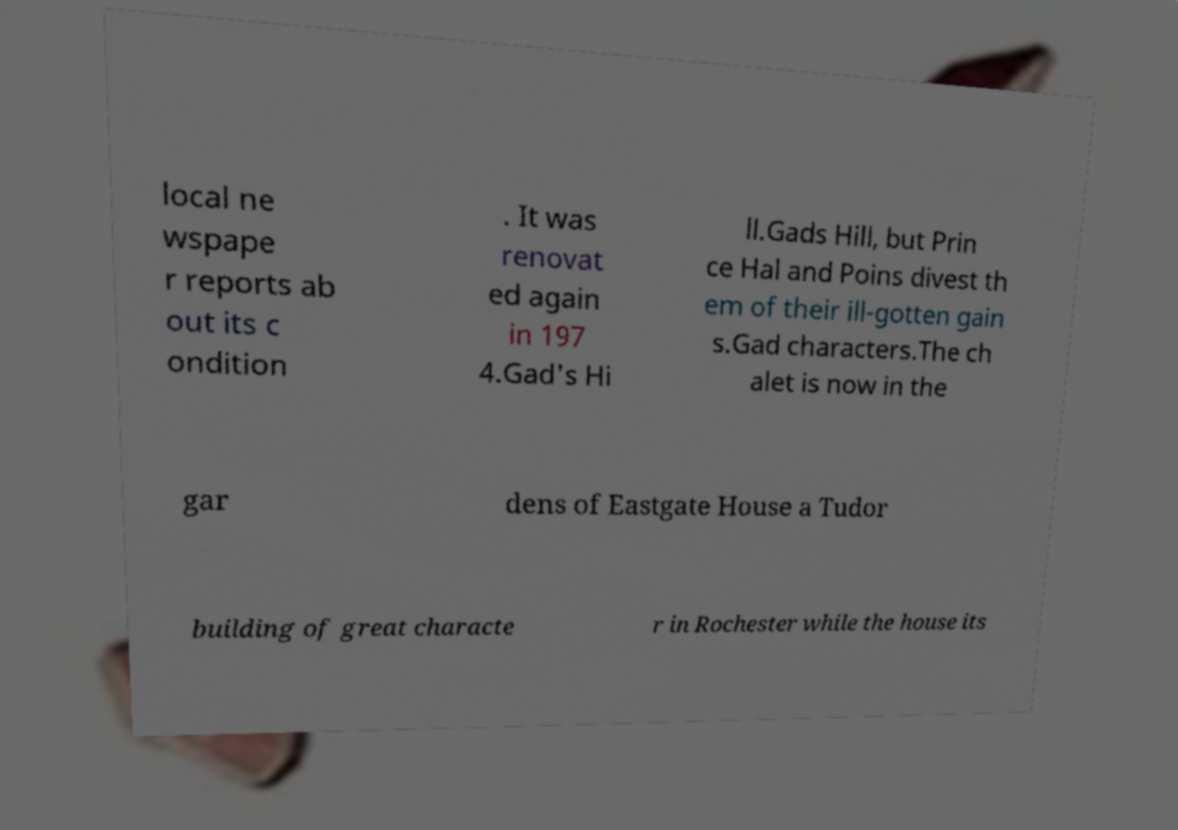Can you accurately transcribe the text from the provided image for me? local ne wspape r reports ab out its c ondition . It was renovat ed again in 197 4.Gad's Hi ll.Gads Hill, but Prin ce Hal and Poins divest th em of their ill-gotten gain s.Gad characters.The ch alet is now in the gar dens of Eastgate House a Tudor building of great characte r in Rochester while the house its 